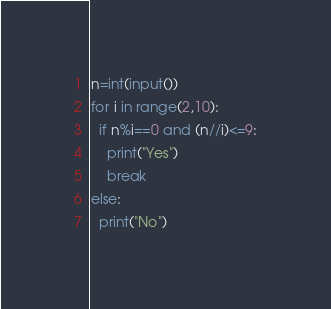<code> <loc_0><loc_0><loc_500><loc_500><_Python_>n=int(input())
for i in range(2,10):
  if n%i==0 and (n//i)<=9:
    print("Yes")
    break
else:
  print("No")</code> 